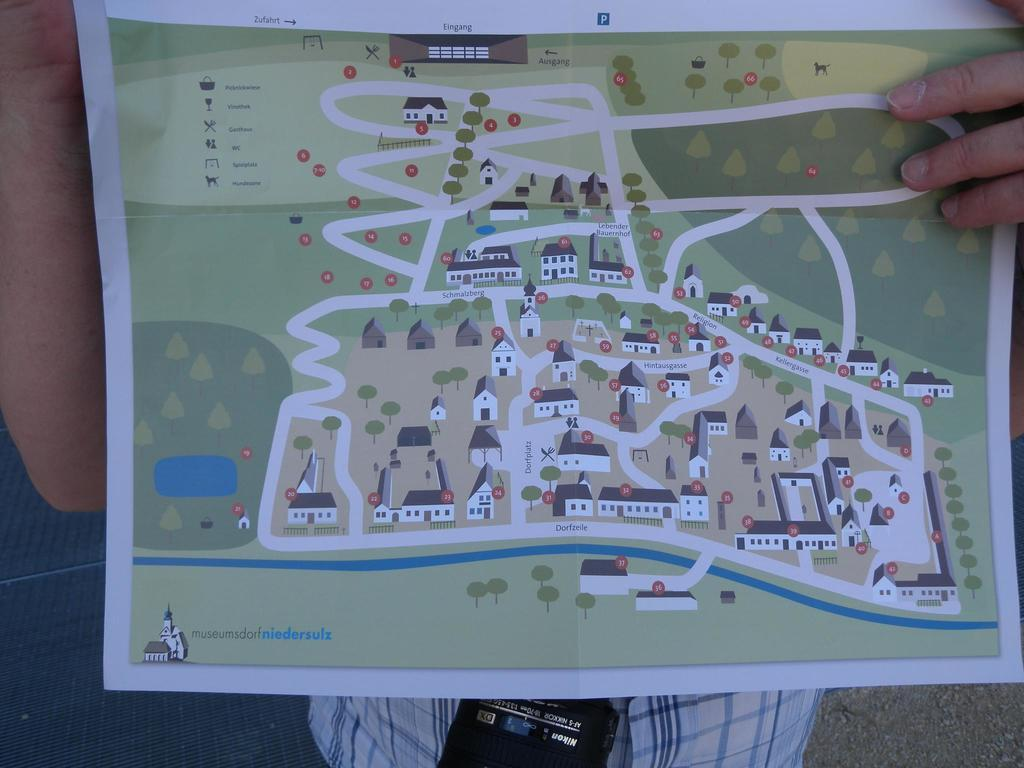What is the main object in the image? There is a paper in the image. What is depicted on the paper? The paper has a cartoon image of houses and other things. Who is holding the paper? The paper is held by a person. What color is the grape that the person is holding in the image? There is no grape present in the image; the person is holding a paper with a cartoon image. What type of amusement can be seen in the cartoon image on the paper? The cartoon image on the paper depicts houses and other things, but it does not show any amusement. 